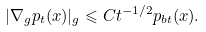Convert formula to latex. <formula><loc_0><loc_0><loc_500><loc_500>| \nabla _ { g } p _ { t } ( x ) | _ { g } \leqslant C t ^ { - 1 / 2 } p _ { b t } ( x ) .</formula> 